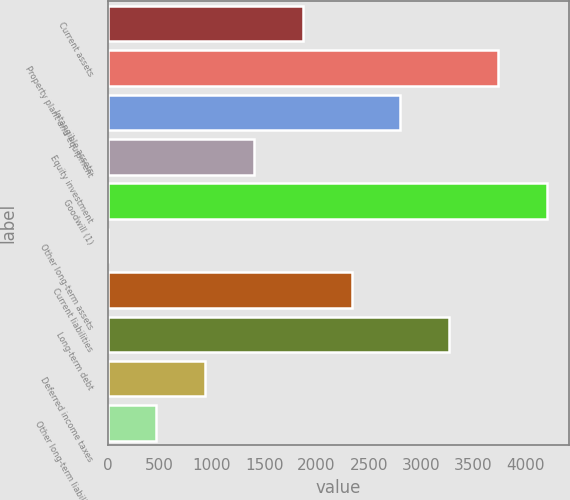<chart> <loc_0><loc_0><loc_500><loc_500><bar_chart><fcel>Current assets<fcel>Property plant and equipment<fcel>Intangible assets<fcel>Equity investment<fcel>Goodwill (1)<fcel>Other long-term assets<fcel>Current liabilities<fcel>Long-term debt<fcel>Deferred income taxes<fcel>Other long-term liabilities<nl><fcel>1868.6<fcel>3736.2<fcel>2802.4<fcel>1401.7<fcel>4203.1<fcel>1<fcel>2335.5<fcel>3269.3<fcel>934.8<fcel>467.9<nl></chart> 